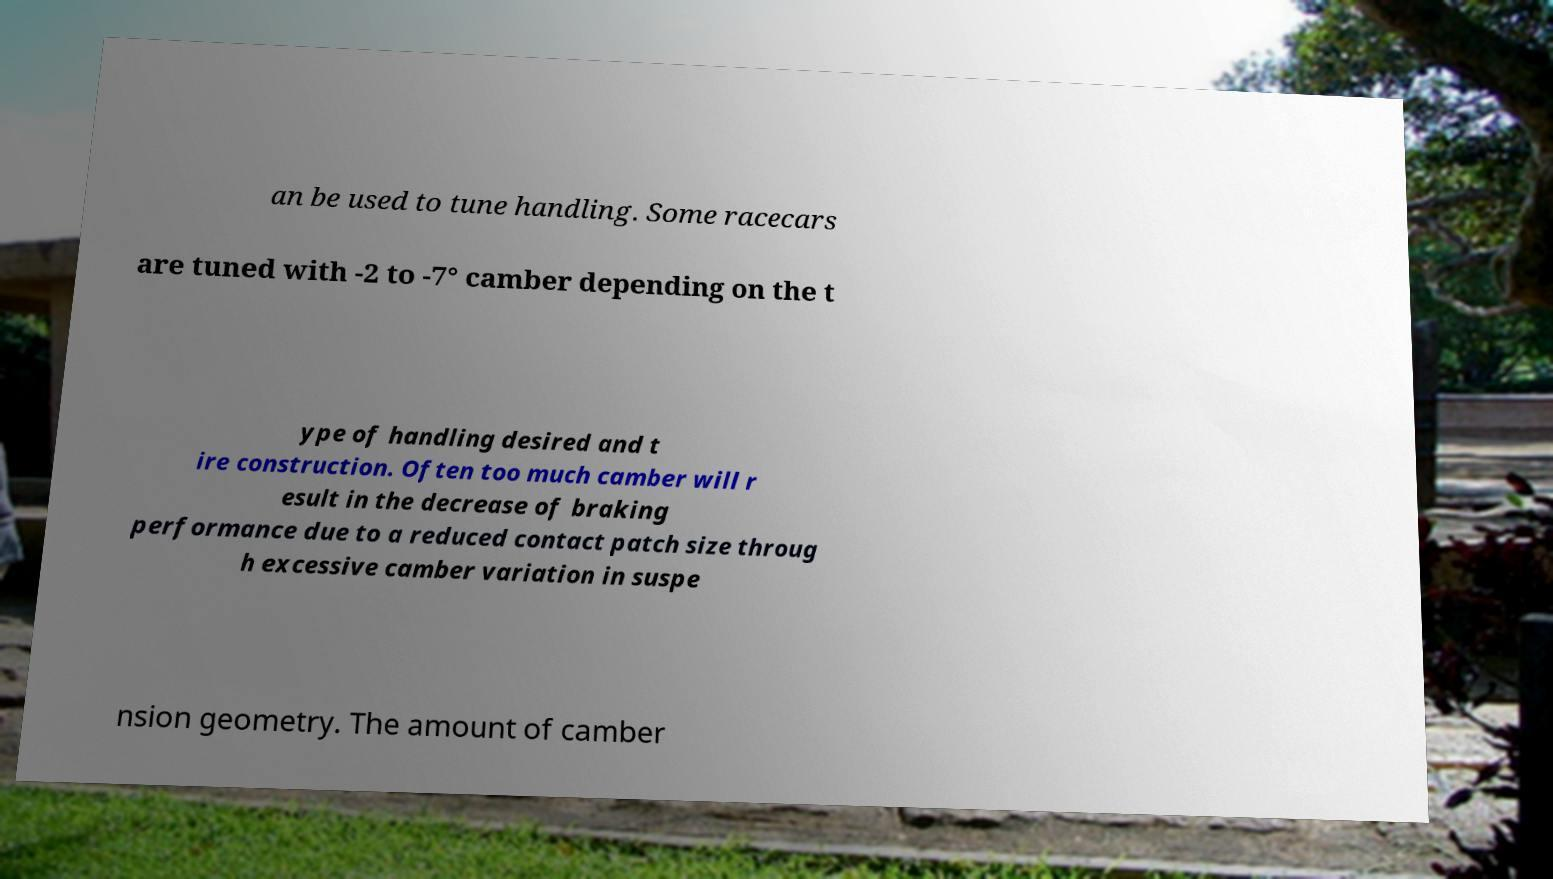Please identify and transcribe the text found in this image. an be used to tune handling. Some racecars are tuned with -2 to -7° camber depending on the t ype of handling desired and t ire construction. Often too much camber will r esult in the decrease of braking performance due to a reduced contact patch size throug h excessive camber variation in suspe nsion geometry. The amount of camber 